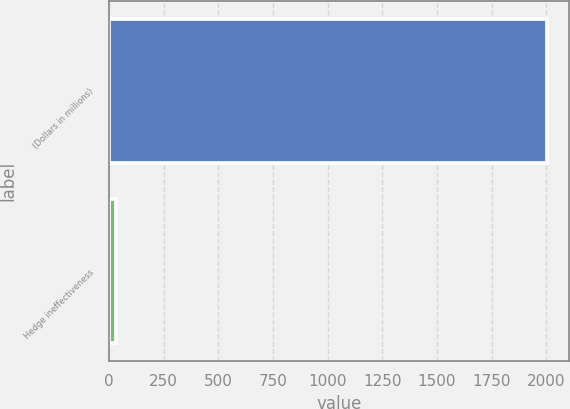Convert chart to OTSL. <chart><loc_0><loc_0><loc_500><loc_500><bar_chart><fcel>(Dollars in millions)<fcel>Hedge ineffectiveness<nl><fcel>2005<fcel>31<nl></chart> 